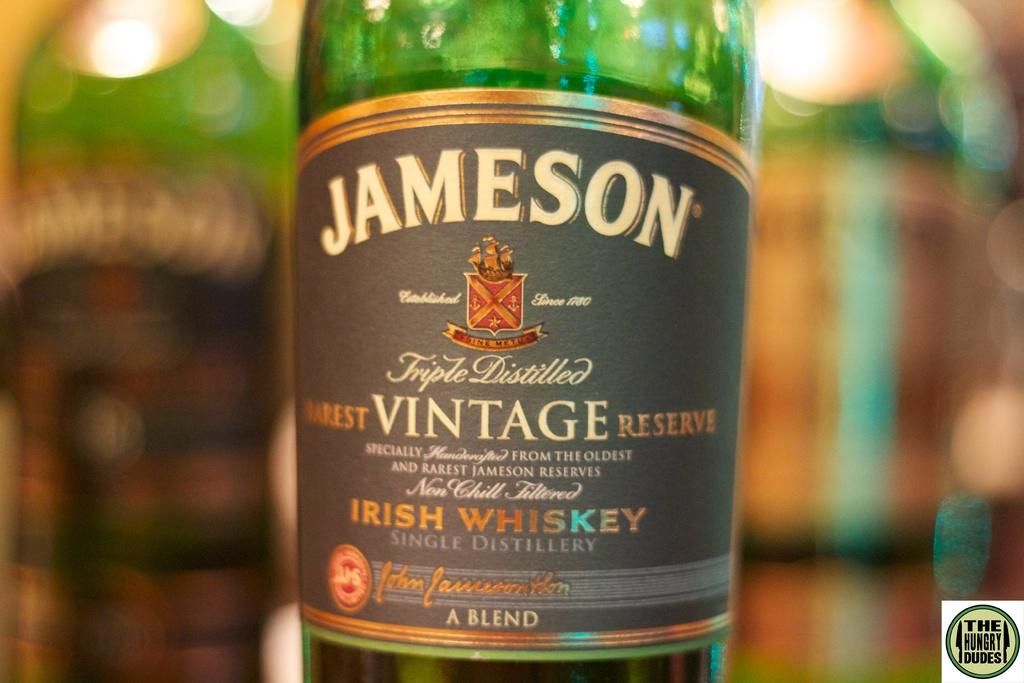<image>
Render a clear and concise summary of the photo. A bottle of Jameson vintage reserve says on the label that it is a blend. 